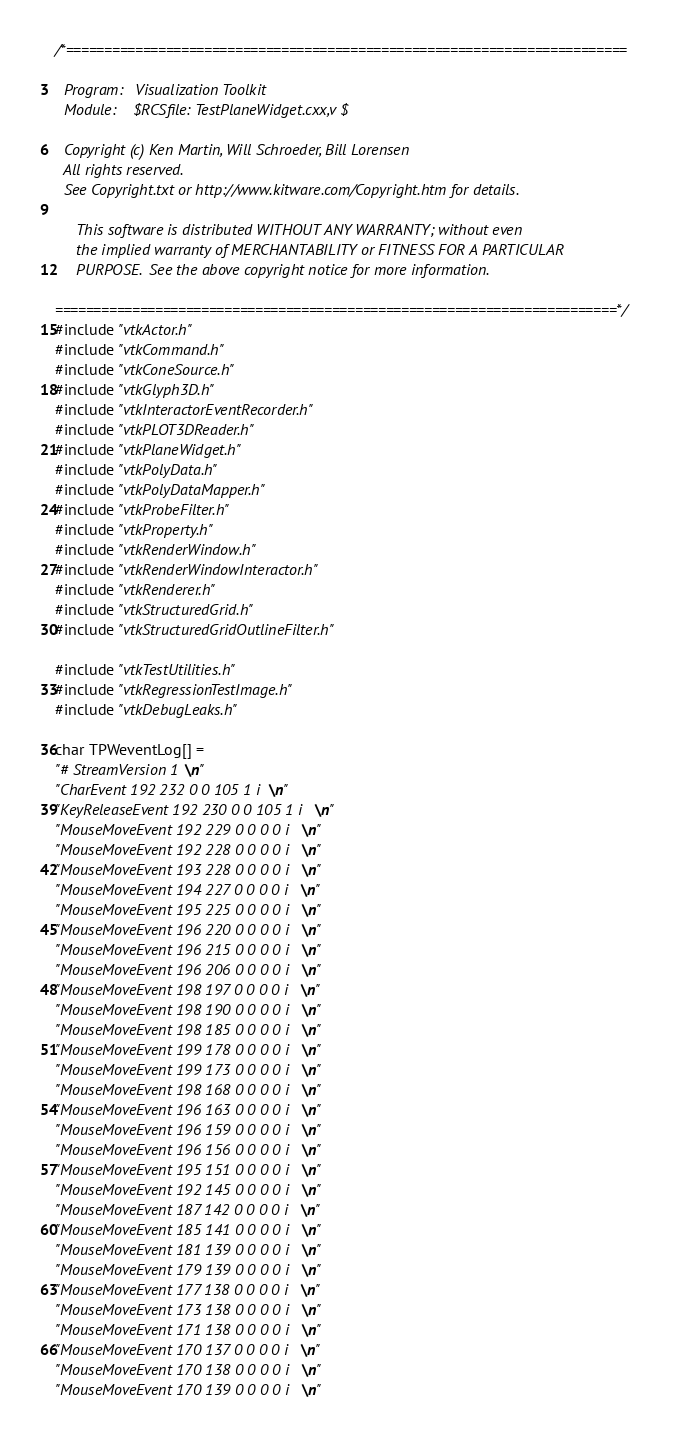<code> <loc_0><loc_0><loc_500><loc_500><_C++_>/*=========================================================================

  Program:   Visualization Toolkit
  Module:    $RCSfile: TestPlaneWidget.cxx,v $

  Copyright (c) Ken Martin, Will Schroeder, Bill Lorensen
  All rights reserved.
  See Copyright.txt or http://www.kitware.com/Copyright.htm for details.

     This software is distributed WITHOUT ANY WARRANTY; without even
     the implied warranty of MERCHANTABILITY or FITNESS FOR A PARTICULAR
     PURPOSE.  See the above copyright notice for more information.

=========================================================================*/
#include "vtkActor.h"
#include "vtkCommand.h"
#include "vtkConeSource.h"
#include "vtkGlyph3D.h"
#include "vtkInteractorEventRecorder.h"
#include "vtkPLOT3DReader.h"
#include "vtkPlaneWidget.h"
#include "vtkPolyData.h"
#include "vtkPolyDataMapper.h"
#include "vtkProbeFilter.h"
#include "vtkProperty.h"
#include "vtkRenderWindow.h"
#include "vtkRenderWindowInteractor.h"
#include "vtkRenderer.h"
#include "vtkStructuredGrid.h"
#include "vtkStructuredGridOutlineFilter.h"

#include "vtkTestUtilities.h"
#include "vtkRegressionTestImage.h"
#include "vtkDebugLeaks.h"

char TPWeventLog[] =
"# StreamVersion 1\n"
"CharEvent 192 232 0 0 105 1 i\n"
"KeyReleaseEvent 192 230 0 0 105 1 i\n"
"MouseMoveEvent 192 229 0 0 0 0 i\n"
"MouseMoveEvent 192 228 0 0 0 0 i\n"
"MouseMoveEvent 193 228 0 0 0 0 i\n"
"MouseMoveEvent 194 227 0 0 0 0 i\n"
"MouseMoveEvent 195 225 0 0 0 0 i\n"
"MouseMoveEvent 196 220 0 0 0 0 i\n"
"MouseMoveEvent 196 215 0 0 0 0 i\n"
"MouseMoveEvent 196 206 0 0 0 0 i\n"
"MouseMoveEvent 198 197 0 0 0 0 i\n"
"MouseMoveEvent 198 190 0 0 0 0 i\n"
"MouseMoveEvent 198 185 0 0 0 0 i\n"
"MouseMoveEvent 199 178 0 0 0 0 i\n"
"MouseMoveEvent 199 173 0 0 0 0 i\n"
"MouseMoveEvent 198 168 0 0 0 0 i\n"
"MouseMoveEvent 196 163 0 0 0 0 i\n"
"MouseMoveEvent 196 159 0 0 0 0 i\n"
"MouseMoveEvent 196 156 0 0 0 0 i\n"
"MouseMoveEvent 195 151 0 0 0 0 i\n"
"MouseMoveEvent 192 145 0 0 0 0 i\n"
"MouseMoveEvent 187 142 0 0 0 0 i\n"
"MouseMoveEvent 185 141 0 0 0 0 i\n"
"MouseMoveEvent 181 139 0 0 0 0 i\n"
"MouseMoveEvent 179 139 0 0 0 0 i\n"
"MouseMoveEvent 177 138 0 0 0 0 i\n"
"MouseMoveEvent 173 138 0 0 0 0 i\n"
"MouseMoveEvent 171 138 0 0 0 0 i\n"
"MouseMoveEvent 170 137 0 0 0 0 i\n"
"MouseMoveEvent 170 138 0 0 0 0 i\n"
"MouseMoveEvent 170 139 0 0 0 0 i\n"</code> 